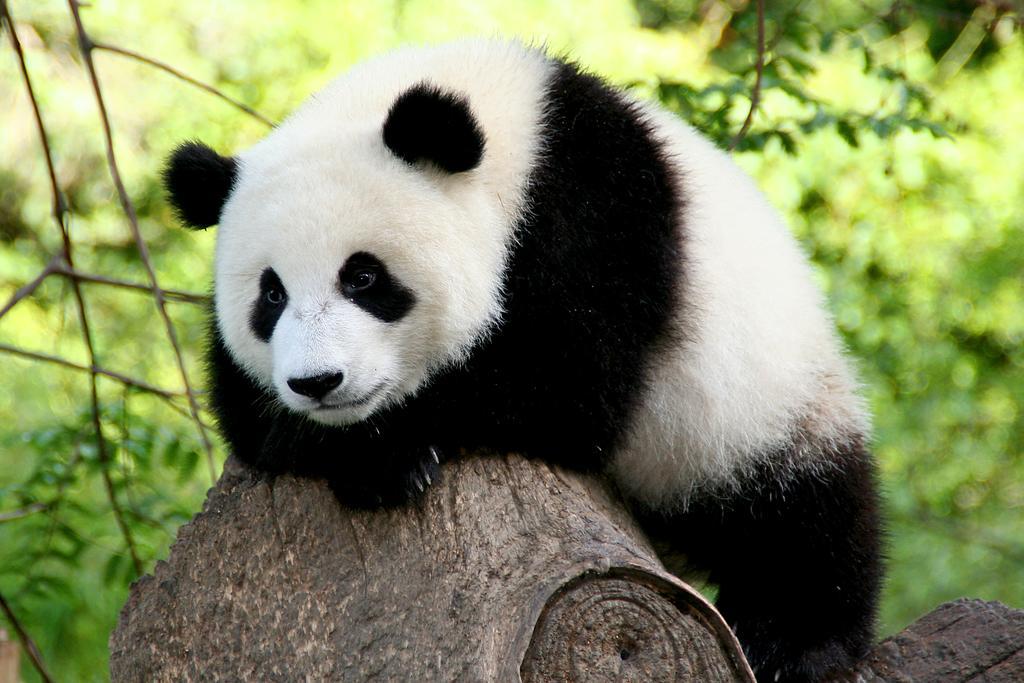Please provide a concise description of this image. Here I can see a panda on a trunk which is looking at the the left side. In the background, I can see the plants. 